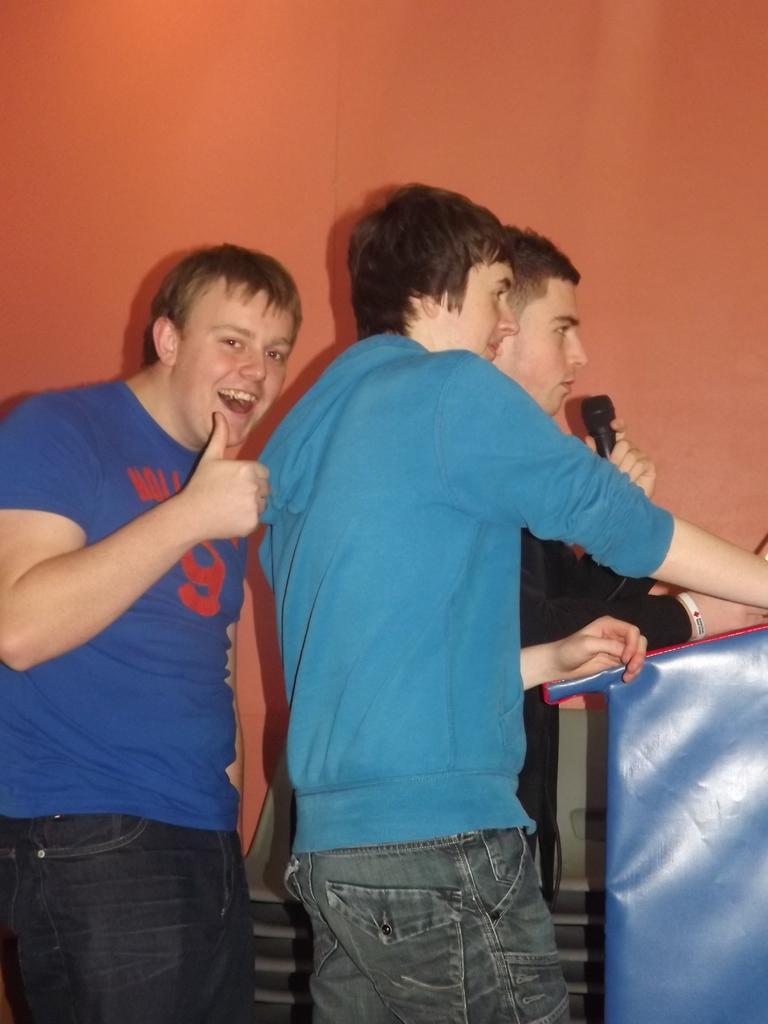Could you give a brief overview of what you see in this image? In the picture we can see three men are standing near the desk and one man is above to talking in the microphone holding it and one man is smiling and in the background we can see a wall which is orange in color. 